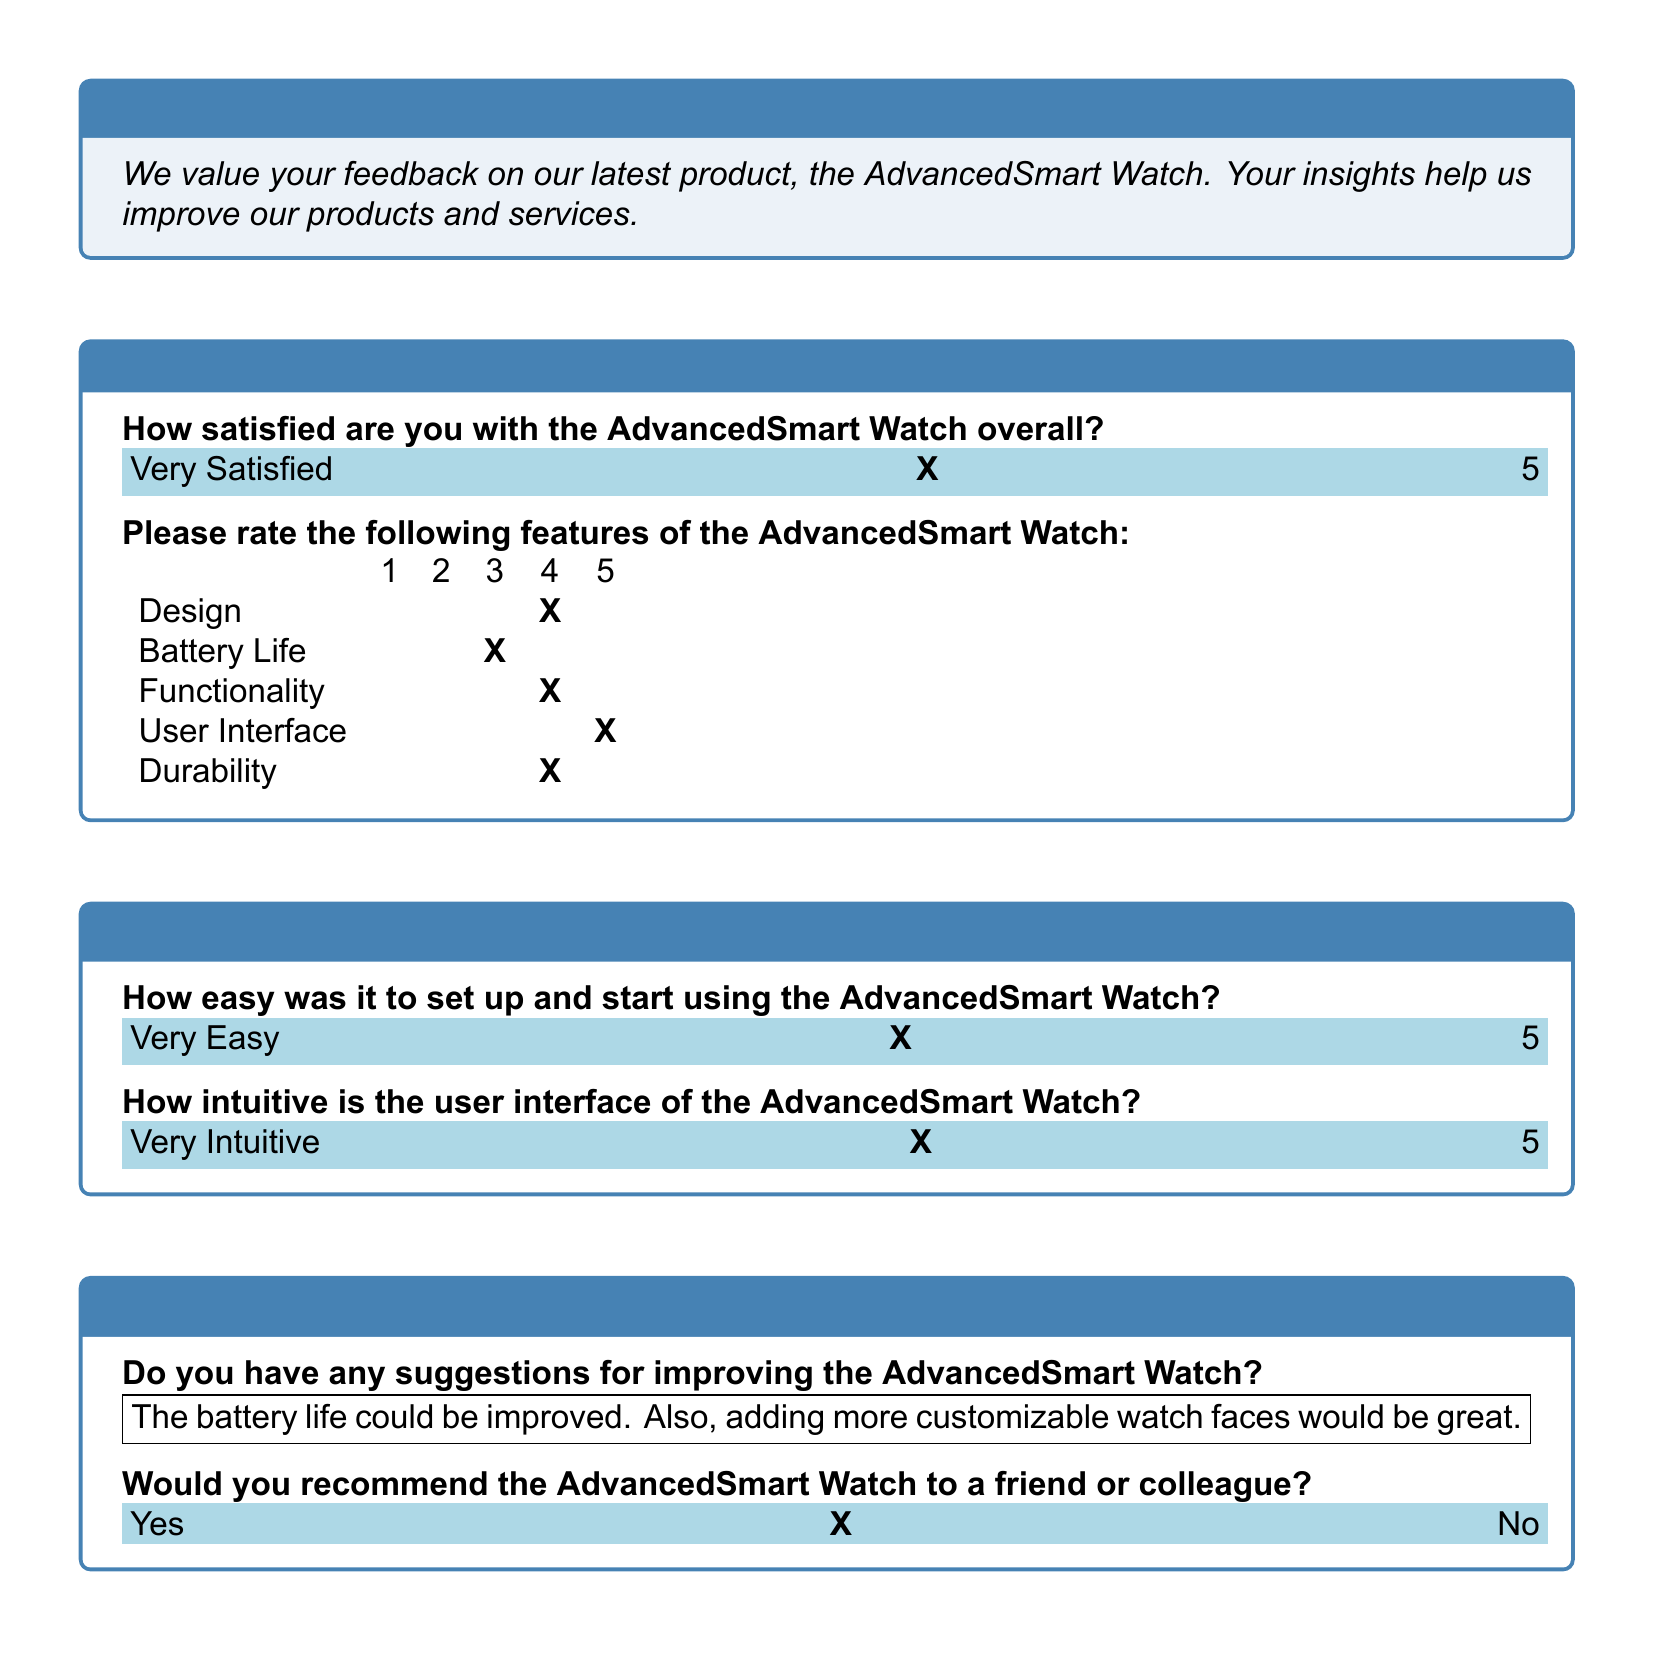How satisfied are respondents with the AdvancedSmart Watch overall? Respondents rated their overall satisfaction on a scale, and the choice marked is "Very Satisfied," indicating the highest level of satisfaction.
Answer: Very Satisfied What is the satisfaction score for the Design feature? The Design feature is rated on a scale of 1 to 5, and the score marked is 4, which reflects a high level of satisfaction.
Answer: 4 What suggestion was provided to improve the AdvancedSmart Watch? A suggestion includes improving the battery life and adding more customizable watch faces, which indicates areas for potential enhancement.
Answer: The battery life could be improved. Also, adding more customizable watch faces would be great How intuitive do users find the user interface? Users rated the intuitiveness of the user interface highly, choosing "Very Intuitive" as their level of agreement.
Answer: Very Intuitive Would respondents recommend the AdvancedSmart Watch? The survey indicates that respondents have a positive perception of the product, as marked 'Yes' suggests they would recommend it to others.
Answer: Yes 